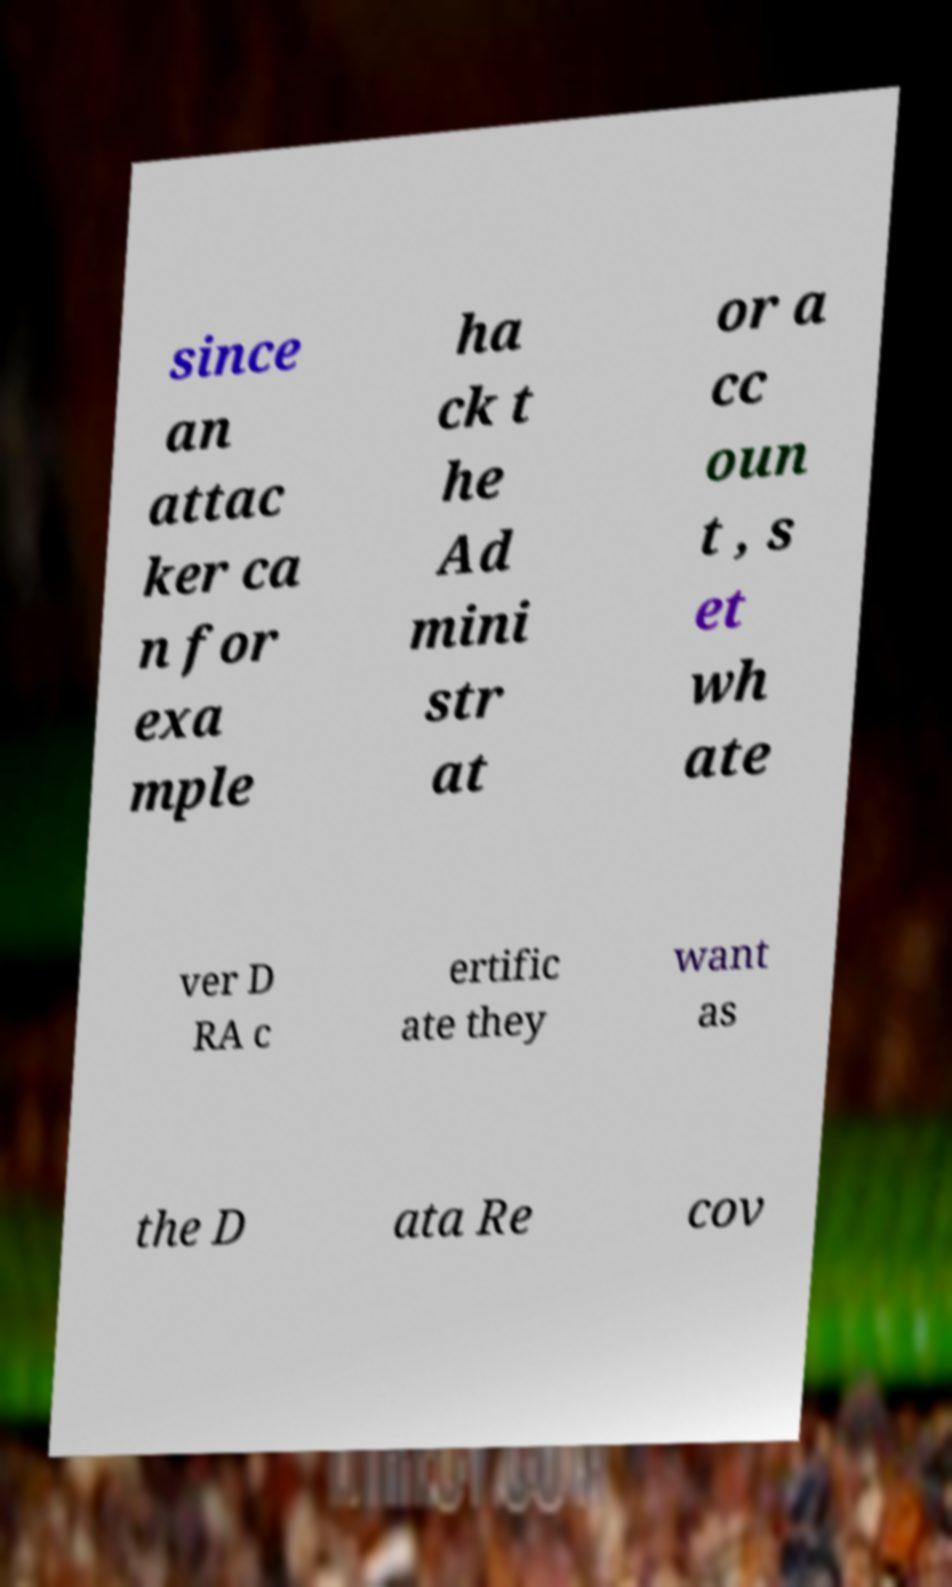I need the written content from this picture converted into text. Can you do that? since an attac ker ca n for exa mple ha ck t he Ad mini str at or a cc oun t , s et wh ate ver D RA c ertific ate they want as the D ata Re cov 